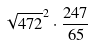<formula> <loc_0><loc_0><loc_500><loc_500>\sqrt { 4 7 2 } ^ { 2 } \cdot \frac { 2 4 7 } { 6 5 }</formula> 